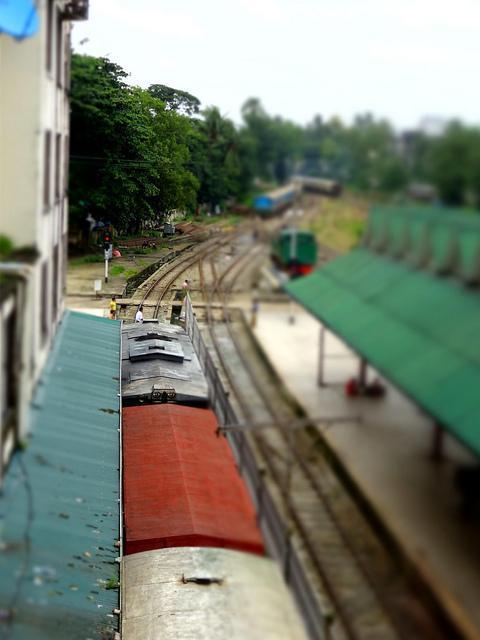How many train segments are visible?
Give a very brief answer. 3. 